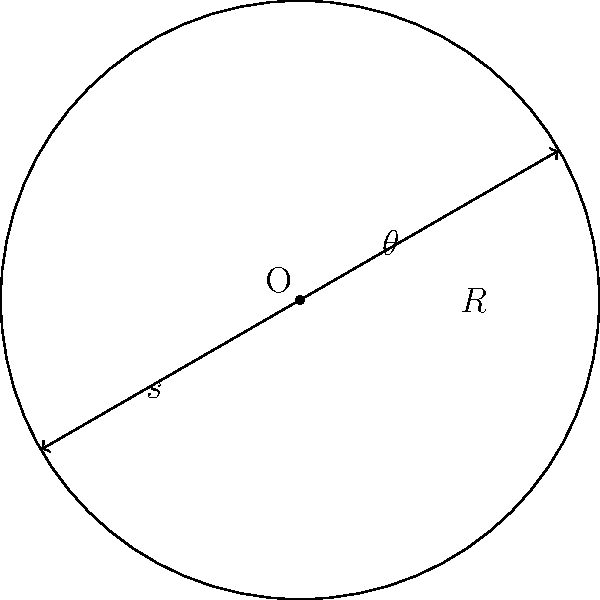As an exotic produce farmer, you're designing a circular garden with a radius of 5 meters to grow rare herbs for fusion cuisine. You want to create concentric rings of herbs, with each ring separated by a constant angle $\theta = 30°$ from the center. If you need a minimum spacing of 0.5 meters between the rows for proper growth, what is the maximum number of concentric rings you can fit in the garden? Let's approach this step-by-step:

1) First, we need to find the length of the arc (s) between two consecutive rings at the outermost edge of the garden. This can be calculated using the formula:

   $s = R\theta$

   Where $R$ is the radius and $\theta$ is the angle in radians.

2) Convert the angle from degrees to radians:
   $\theta = 30° \times \frac{\pi}{180°} = \frac{\pi}{6}$ radians

3) Now we can calculate s:
   $s = 5 \times \frac{\pi}{6} \approx 2.618$ meters

4) The spacing between rows should be at least 0.5 meters. To find the maximum number of rings, we divide the total radius by the minimum spacing:

   $\text{Max rings} = \frac{R}{\text{min spacing}} = \frac{5}{0.5} = 10$

5) However, this doesn't account for the curvature of the circle. We need to check if the arc length at the outermost ring is greater than or equal to the minimum spacing:

   $2.618 > 0.5$, so our calculation in step 4 is valid.

6) Since we can't have a partial ring, we round down to the nearest whole number.

Therefore, the maximum number of concentric rings that can fit in the garden is 10.
Answer: 10 rings 